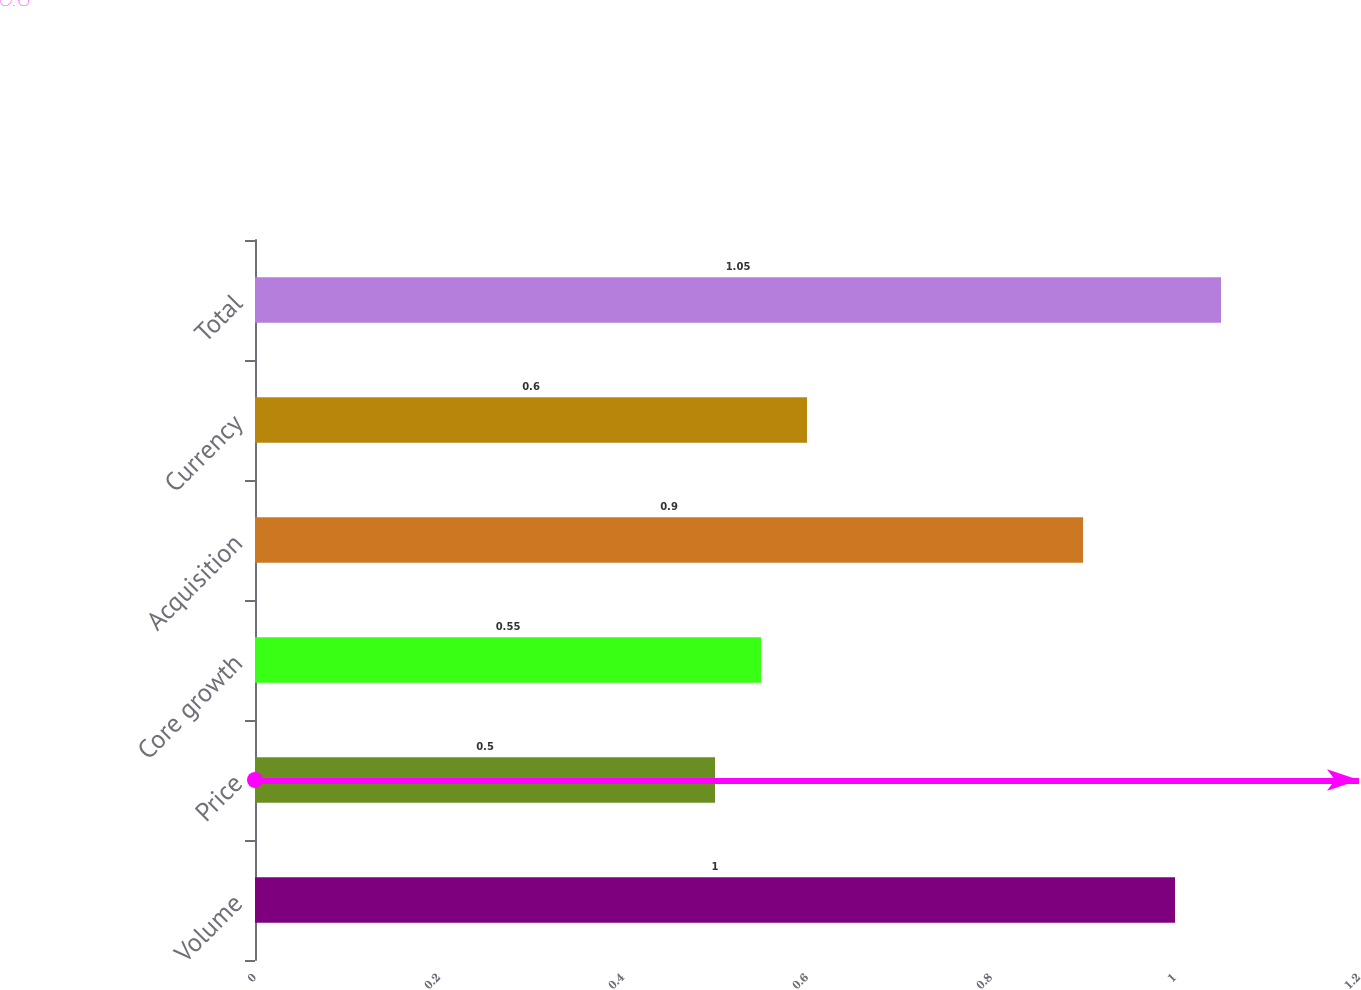Convert chart. <chart><loc_0><loc_0><loc_500><loc_500><bar_chart><fcel>Volume<fcel>Price<fcel>Core growth<fcel>Acquisition<fcel>Currency<fcel>Total<nl><fcel>1<fcel>0.5<fcel>0.55<fcel>0.9<fcel>0.6<fcel>1.05<nl></chart> 